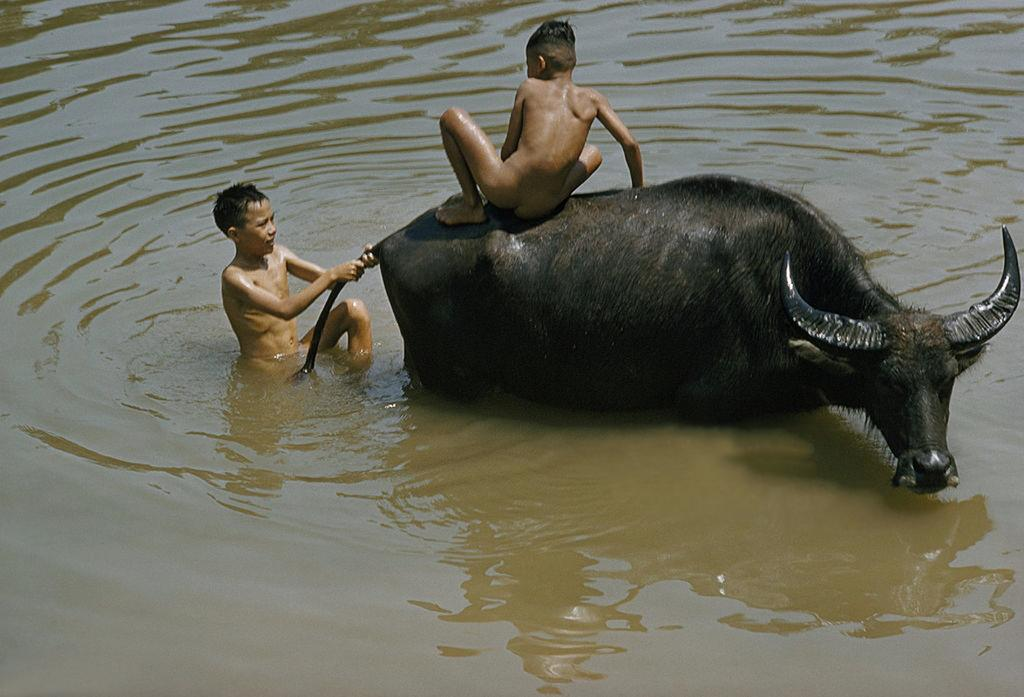What is the boy doing in the image? There is a boy sitting on the buffalo, and another boy is standing and holding the tail of the buffalo. Can you describe the position of the buffalo in the image? The buffalo is in contact with water at the bottom of the image. What is the income of the ghost in the image? There is no ghost present in the image, so it is not possible to determine its income. 